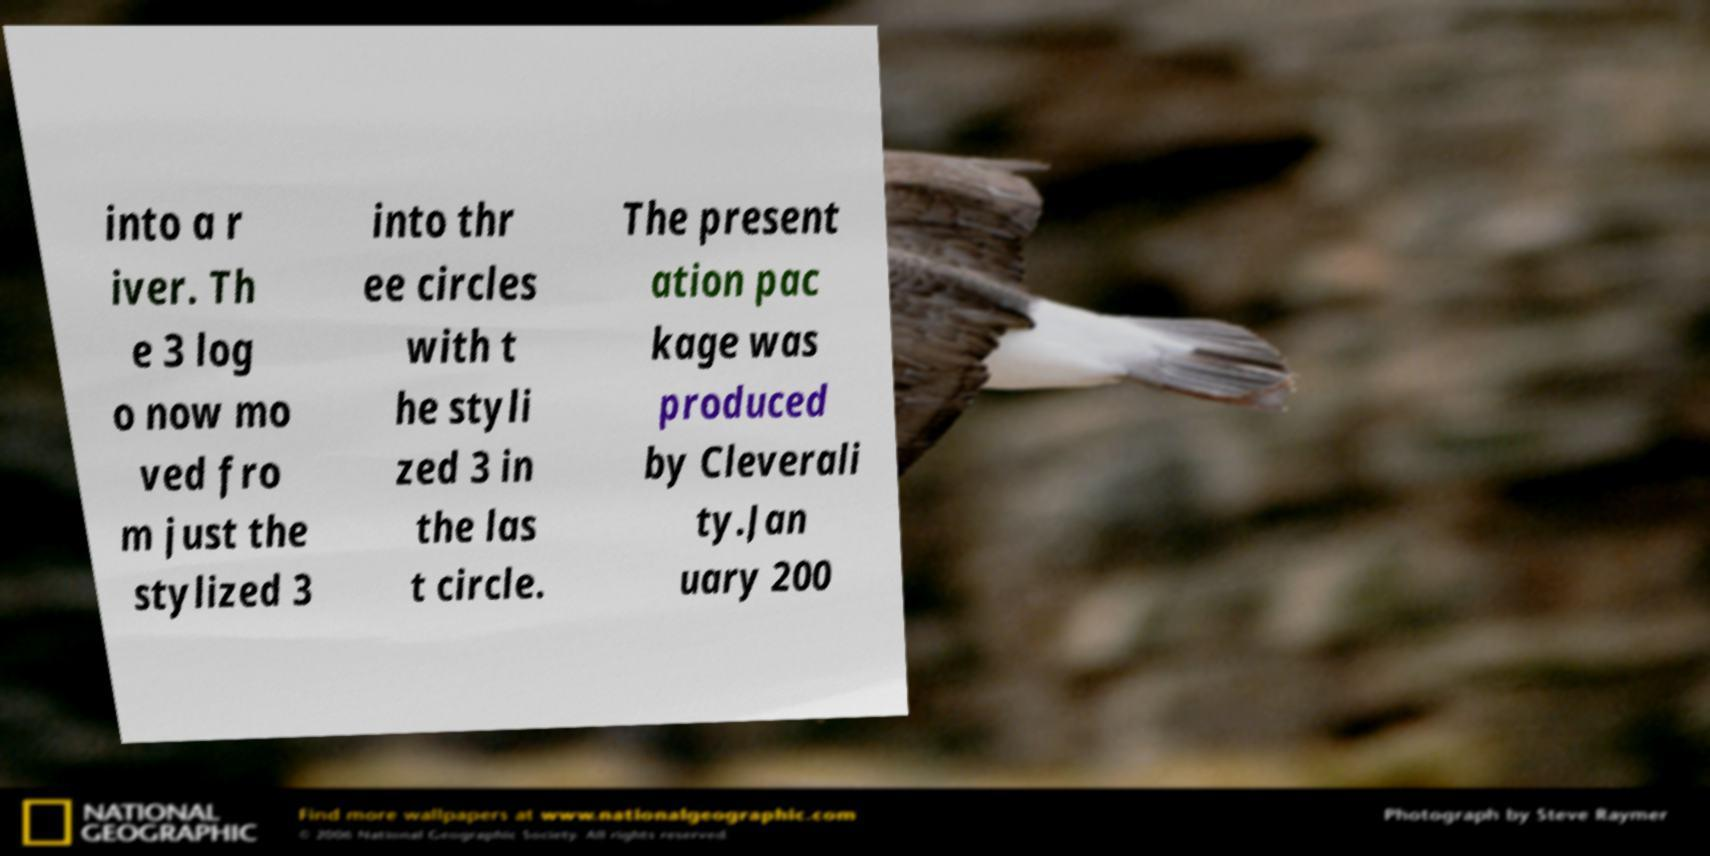Can you read and provide the text displayed in the image?This photo seems to have some interesting text. Can you extract and type it out for me? into a r iver. Th e 3 log o now mo ved fro m just the stylized 3 into thr ee circles with t he styli zed 3 in the las t circle. The present ation pac kage was produced by Cleverali ty.Jan uary 200 